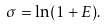<formula> <loc_0><loc_0><loc_500><loc_500>\sigma = \ln ( 1 + E ) .</formula> 